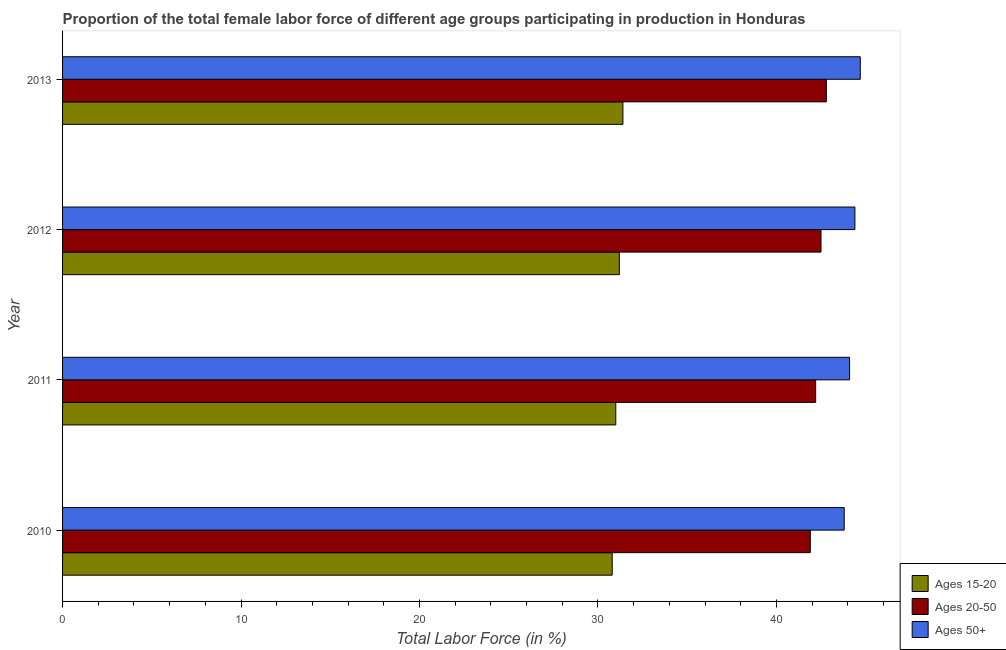How many different coloured bars are there?
Give a very brief answer. 3. Are the number of bars per tick equal to the number of legend labels?
Your answer should be compact. Yes. How many bars are there on the 1st tick from the top?
Provide a short and direct response. 3. What is the label of the 2nd group of bars from the top?
Give a very brief answer. 2012. In how many cases, is the number of bars for a given year not equal to the number of legend labels?
Your answer should be very brief. 0. What is the percentage of female labor force within the age group 15-20 in 2010?
Make the answer very short. 30.8. Across all years, what is the maximum percentage of female labor force within the age group 15-20?
Your answer should be very brief. 31.4. Across all years, what is the minimum percentage of female labor force within the age group 15-20?
Offer a very short reply. 30.8. What is the total percentage of female labor force within the age group 15-20 in the graph?
Make the answer very short. 124.4. What is the difference between the percentage of female labor force within the age group 15-20 in 2010 and that in 2012?
Ensure brevity in your answer.  -0.4. What is the difference between the percentage of female labor force above age 50 in 2010 and the percentage of female labor force within the age group 15-20 in 2012?
Provide a succinct answer. 12.6. What is the average percentage of female labor force above age 50 per year?
Your answer should be compact. 44.25. In the year 2010, what is the difference between the percentage of female labor force within the age group 15-20 and percentage of female labor force within the age group 20-50?
Provide a succinct answer. -11.1. Is the percentage of female labor force within the age group 20-50 in 2010 less than that in 2013?
Provide a short and direct response. Yes. Is the difference between the percentage of female labor force within the age group 20-50 in 2010 and 2013 greater than the difference between the percentage of female labor force above age 50 in 2010 and 2013?
Provide a short and direct response. Yes. What is the difference between the highest and the second highest percentage of female labor force within the age group 20-50?
Offer a very short reply. 0.3. What is the difference between the highest and the lowest percentage of female labor force within the age group 15-20?
Your answer should be very brief. 0.6. What does the 3rd bar from the top in 2010 represents?
Your response must be concise. Ages 15-20. What does the 3rd bar from the bottom in 2013 represents?
Provide a succinct answer. Ages 50+. Is it the case that in every year, the sum of the percentage of female labor force within the age group 15-20 and percentage of female labor force within the age group 20-50 is greater than the percentage of female labor force above age 50?
Offer a terse response. Yes. How many bars are there?
Keep it short and to the point. 12. Are all the bars in the graph horizontal?
Provide a succinct answer. Yes. Does the graph contain grids?
Provide a short and direct response. No. How are the legend labels stacked?
Ensure brevity in your answer.  Vertical. What is the title of the graph?
Your answer should be very brief. Proportion of the total female labor force of different age groups participating in production in Honduras. Does "Czech Republic" appear as one of the legend labels in the graph?
Ensure brevity in your answer.  No. What is the Total Labor Force (in %) of Ages 15-20 in 2010?
Offer a terse response. 30.8. What is the Total Labor Force (in %) of Ages 20-50 in 2010?
Your answer should be very brief. 41.9. What is the Total Labor Force (in %) in Ages 50+ in 2010?
Provide a short and direct response. 43.8. What is the Total Labor Force (in %) of Ages 15-20 in 2011?
Your answer should be very brief. 31. What is the Total Labor Force (in %) in Ages 20-50 in 2011?
Make the answer very short. 42.2. What is the Total Labor Force (in %) in Ages 50+ in 2011?
Keep it short and to the point. 44.1. What is the Total Labor Force (in %) of Ages 15-20 in 2012?
Offer a very short reply. 31.2. What is the Total Labor Force (in %) in Ages 20-50 in 2012?
Your answer should be compact. 42.5. What is the Total Labor Force (in %) in Ages 50+ in 2012?
Your response must be concise. 44.4. What is the Total Labor Force (in %) in Ages 15-20 in 2013?
Provide a succinct answer. 31.4. What is the Total Labor Force (in %) of Ages 20-50 in 2013?
Your response must be concise. 42.8. What is the Total Labor Force (in %) of Ages 50+ in 2013?
Make the answer very short. 44.7. Across all years, what is the maximum Total Labor Force (in %) in Ages 15-20?
Provide a succinct answer. 31.4. Across all years, what is the maximum Total Labor Force (in %) of Ages 20-50?
Make the answer very short. 42.8. Across all years, what is the maximum Total Labor Force (in %) in Ages 50+?
Offer a terse response. 44.7. Across all years, what is the minimum Total Labor Force (in %) in Ages 15-20?
Offer a very short reply. 30.8. Across all years, what is the minimum Total Labor Force (in %) of Ages 20-50?
Make the answer very short. 41.9. Across all years, what is the minimum Total Labor Force (in %) in Ages 50+?
Keep it short and to the point. 43.8. What is the total Total Labor Force (in %) of Ages 15-20 in the graph?
Provide a succinct answer. 124.4. What is the total Total Labor Force (in %) in Ages 20-50 in the graph?
Offer a terse response. 169.4. What is the total Total Labor Force (in %) of Ages 50+ in the graph?
Your answer should be very brief. 177. What is the difference between the Total Labor Force (in %) of Ages 15-20 in 2010 and that in 2011?
Your answer should be very brief. -0.2. What is the difference between the Total Labor Force (in %) of Ages 20-50 in 2010 and that in 2011?
Offer a terse response. -0.3. What is the difference between the Total Labor Force (in %) of Ages 50+ in 2010 and that in 2011?
Provide a succinct answer. -0.3. What is the difference between the Total Labor Force (in %) of Ages 20-50 in 2010 and that in 2012?
Provide a short and direct response. -0.6. What is the difference between the Total Labor Force (in %) in Ages 20-50 in 2010 and that in 2013?
Provide a short and direct response. -0.9. What is the difference between the Total Labor Force (in %) in Ages 50+ in 2010 and that in 2013?
Your answer should be very brief. -0.9. What is the difference between the Total Labor Force (in %) in Ages 50+ in 2011 and that in 2012?
Make the answer very short. -0.3. What is the difference between the Total Labor Force (in %) of Ages 15-20 in 2011 and that in 2013?
Your response must be concise. -0.4. What is the difference between the Total Labor Force (in %) in Ages 20-50 in 2011 and that in 2013?
Your response must be concise. -0.6. What is the difference between the Total Labor Force (in %) in Ages 15-20 in 2012 and that in 2013?
Keep it short and to the point. -0.2. What is the difference between the Total Labor Force (in %) in Ages 20-50 in 2012 and that in 2013?
Provide a short and direct response. -0.3. What is the difference between the Total Labor Force (in %) of Ages 50+ in 2012 and that in 2013?
Keep it short and to the point. -0.3. What is the difference between the Total Labor Force (in %) of Ages 15-20 in 2010 and the Total Labor Force (in %) of Ages 20-50 in 2011?
Keep it short and to the point. -11.4. What is the difference between the Total Labor Force (in %) in Ages 15-20 in 2010 and the Total Labor Force (in %) in Ages 50+ in 2011?
Offer a very short reply. -13.3. What is the difference between the Total Labor Force (in %) of Ages 20-50 in 2010 and the Total Labor Force (in %) of Ages 50+ in 2011?
Provide a short and direct response. -2.2. What is the difference between the Total Labor Force (in %) in Ages 20-50 in 2010 and the Total Labor Force (in %) in Ages 50+ in 2012?
Ensure brevity in your answer.  -2.5. What is the difference between the Total Labor Force (in %) in Ages 15-20 in 2010 and the Total Labor Force (in %) in Ages 50+ in 2013?
Your response must be concise. -13.9. What is the difference between the Total Labor Force (in %) in Ages 15-20 in 2011 and the Total Labor Force (in %) in Ages 50+ in 2013?
Give a very brief answer. -13.7. What is the difference between the Total Labor Force (in %) of Ages 20-50 in 2011 and the Total Labor Force (in %) of Ages 50+ in 2013?
Provide a short and direct response. -2.5. What is the difference between the Total Labor Force (in %) of Ages 15-20 in 2012 and the Total Labor Force (in %) of Ages 50+ in 2013?
Keep it short and to the point. -13.5. What is the difference between the Total Labor Force (in %) in Ages 20-50 in 2012 and the Total Labor Force (in %) in Ages 50+ in 2013?
Make the answer very short. -2.2. What is the average Total Labor Force (in %) of Ages 15-20 per year?
Make the answer very short. 31.1. What is the average Total Labor Force (in %) in Ages 20-50 per year?
Offer a terse response. 42.35. What is the average Total Labor Force (in %) of Ages 50+ per year?
Provide a succinct answer. 44.25. In the year 2010, what is the difference between the Total Labor Force (in %) in Ages 15-20 and Total Labor Force (in %) in Ages 20-50?
Offer a very short reply. -11.1. In the year 2010, what is the difference between the Total Labor Force (in %) of Ages 15-20 and Total Labor Force (in %) of Ages 50+?
Make the answer very short. -13. In the year 2011, what is the difference between the Total Labor Force (in %) in Ages 15-20 and Total Labor Force (in %) in Ages 20-50?
Your answer should be compact. -11.2. In the year 2011, what is the difference between the Total Labor Force (in %) of Ages 20-50 and Total Labor Force (in %) of Ages 50+?
Give a very brief answer. -1.9. In the year 2012, what is the difference between the Total Labor Force (in %) of Ages 15-20 and Total Labor Force (in %) of Ages 20-50?
Give a very brief answer. -11.3. In the year 2012, what is the difference between the Total Labor Force (in %) in Ages 15-20 and Total Labor Force (in %) in Ages 50+?
Provide a short and direct response. -13.2. In the year 2013, what is the difference between the Total Labor Force (in %) in Ages 15-20 and Total Labor Force (in %) in Ages 20-50?
Provide a succinct answer. -11.4. In the year 2013, what is the difference between the Total Labor Force (in %) of Ages 15-20 and Total Labor Force (in %) of Ages 50+?
Your response must be concise. -13.3. What is the ratio of the Total Labor Force (in %) in Ages 15-20 in 2010 to that in 2012?
Provide a succinct answer. 0.99. What is the ratio of the Total Labor Force (in %) in Ages 20-50 in 2010 to that in 2012?
Keep it short and to the point. 0.99. What is the ratio of the Total Labor Force (in %) in Ages 50+ in 2010 to that in 2012?
Your answer should be compact. 0.99. What is the ratio of the Total Labor Force (in %) of Ages 15-20 in 2010 to that in 2013?
Keep it short and to the point. 0.98. What is the ratio of the Total Labor Force (in %) in Ages 20-50 in 2010 to that in 2013?
Your answer should be compact. 0.98. What is the ratio of the Total Labor Force (in %) of Ages 50+ in 2010 to that in 2013?
Your answer should be compact. 0.98. What is the ratio of the Total Labor Force (in %) of Ages 15-20 in 2011 to that in 2012?
Ensure brevity in your answer.  0.99. What is the ratio of the Total Labor Force (in %) of Ages 20-50 in 2011 to that in 2012?
Your answer should be very brief. 0.99. What is the ratio of the Total Labor Force (in %) in Ages 50+ in 2011 to that in 2012?
Offer a terse response. 0.99. What is the ratio of the Total Labor Force (in %) of Ages 15-20 in 2011 to that in 2013?
Your answer should be very brief. 0.99. What is the ratio of the Total Labor Force (in %) in Ages 50+ in 2011 to that in 2013?
Offer a terse response. 0.99. What is the ratio of the Total Labor Force (in %) of Ages 20-50 in 2012 to that in 2013?
Ensure brevity in your answer.  0.99. What is the difference between the highest and the second highest Total Labor Force (in %) of Ages 20-50?
Your answer should be compact. 0.3. What is the difference between the highest and the lowest Total Labor Force (in %) of Ages 50+?
Your response must be concise. 0.9. 